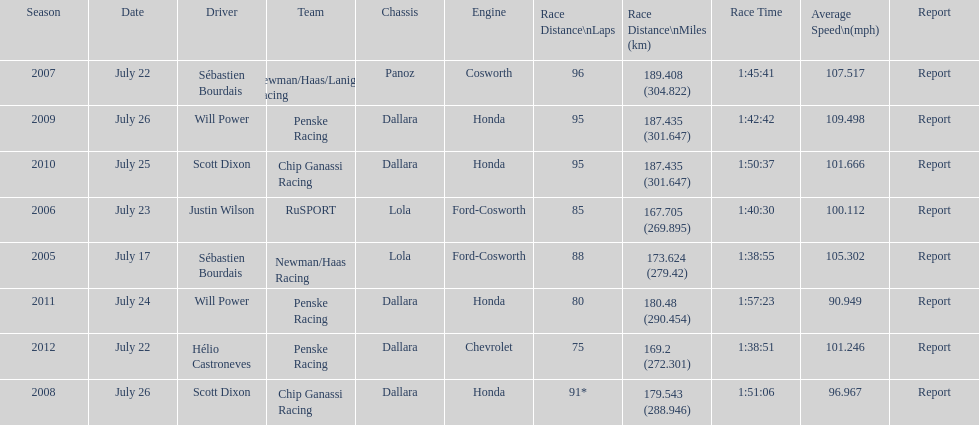I'm looking to parse the entire table for insights. Could you assist me with that? {'header': ['Season', 'Date', 'Driver', 'Team', 'Chassis', 'Engine', 'Race Distance\\nLaps', 'Race Distance\\nMiles (km)', 'Race Time', 'Average Speed\\n(mph)', 'Report'], 'rows': [['2007', 'July 22', 'Sébastien Bourdais', 'Newman/Haas/Lanigan Racing', 'Panoz', 'Cosworth', '96', '189.408 (304.822)', '1:45:41', '107.517', 'Report'], ['2009', 'July 26', 'Will Power', 'Penske Racing', 'Dallara', 'Honda', '95', '187.435 (301.647)', '1:42:42', '109.498', 'Report'], ['2010', 'July 25', 'Scott Dixon', 'Chip Ganassi Racing', 'Dallara', 'Honda', '95', '187.435 (301.647)', '1:50:37', '101.666', 'Report'], ['2006', 'July 23', 'Justin Wilson', 'RuSPORT', 'Lola', 'Ford-Cosworth', '85', '167.705 (269.895)', '1:40:30', '100.112', 'Report'], ['2005', 'July 17', 'Sébastien Bourdais', 'Newman/Haas Racing', 'Lola', 'Ford-Cosworth', '88', '173.624 (279.42)', '1:38:55', '105.302', 'Report'], ['2011', 'July 24', 'Will Power', 'Penske Racing', 'Dallara', 'Honda', '80', '180.48 (290.454)', '1:57:23', '90.949', 'Report'], ['2012', 'July 22', 'Hélio Castroneves', 'Penske Racing', 'Dallara', 'Chevrolet', '75', '169.2 (272.301)', '1:38:51', '101.246', 'Report'], ['2008', 'July 26', 'Scott Dixon', 'Chip Ganassi Racing', 'Dallara', 'Honda', '91*', '179.543 (288.946)', '1:51:06', '96.967', 'Report']]} Which team won the champ car world series the year before rusport? Newman/Haas Racing. 